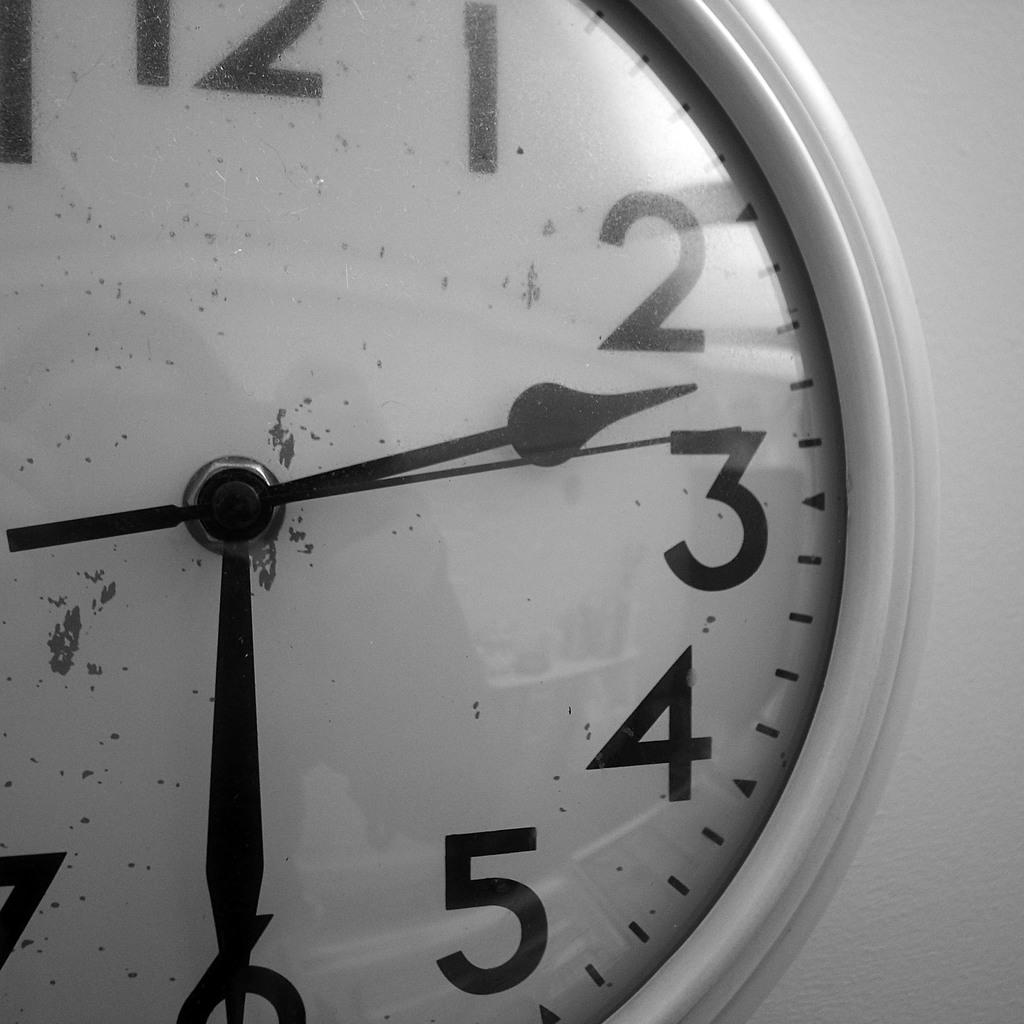What is number on the left center?
Your answer should be very brief. 3. 